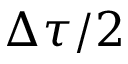<formula> <loc_0><loc_0><loc_500><loc_500>\Delta \tau / 2</formula> 